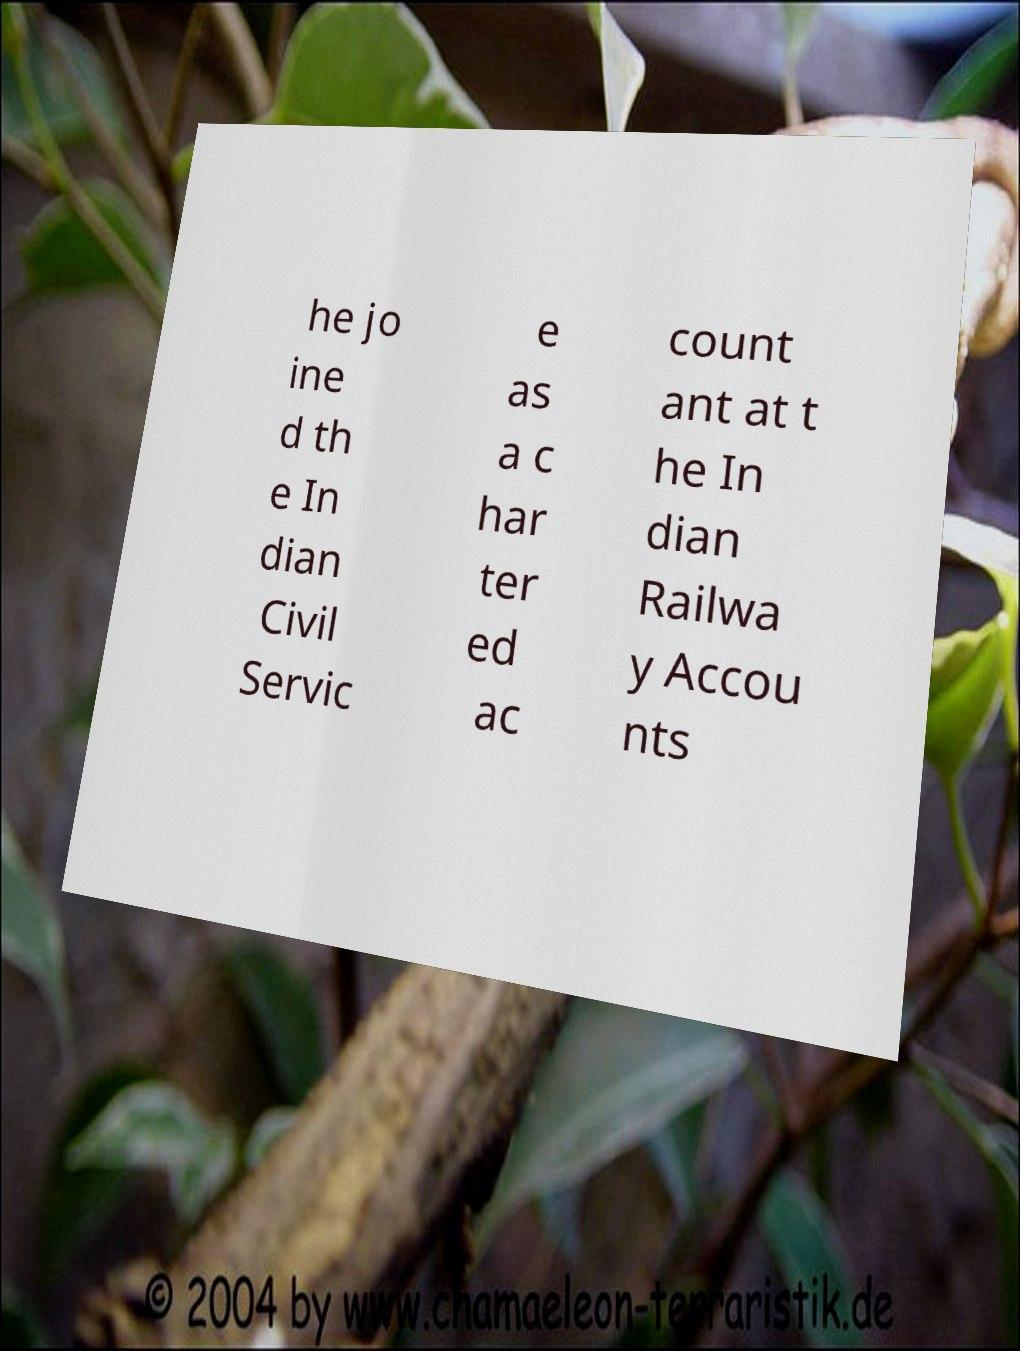For documentation purposes, I need the text within this image transcribed. Could you provide that? he jo ine d th e In dian Civil Servic e as a c har ter ed ac count ant at t he In dian Railwa y Accou nts 